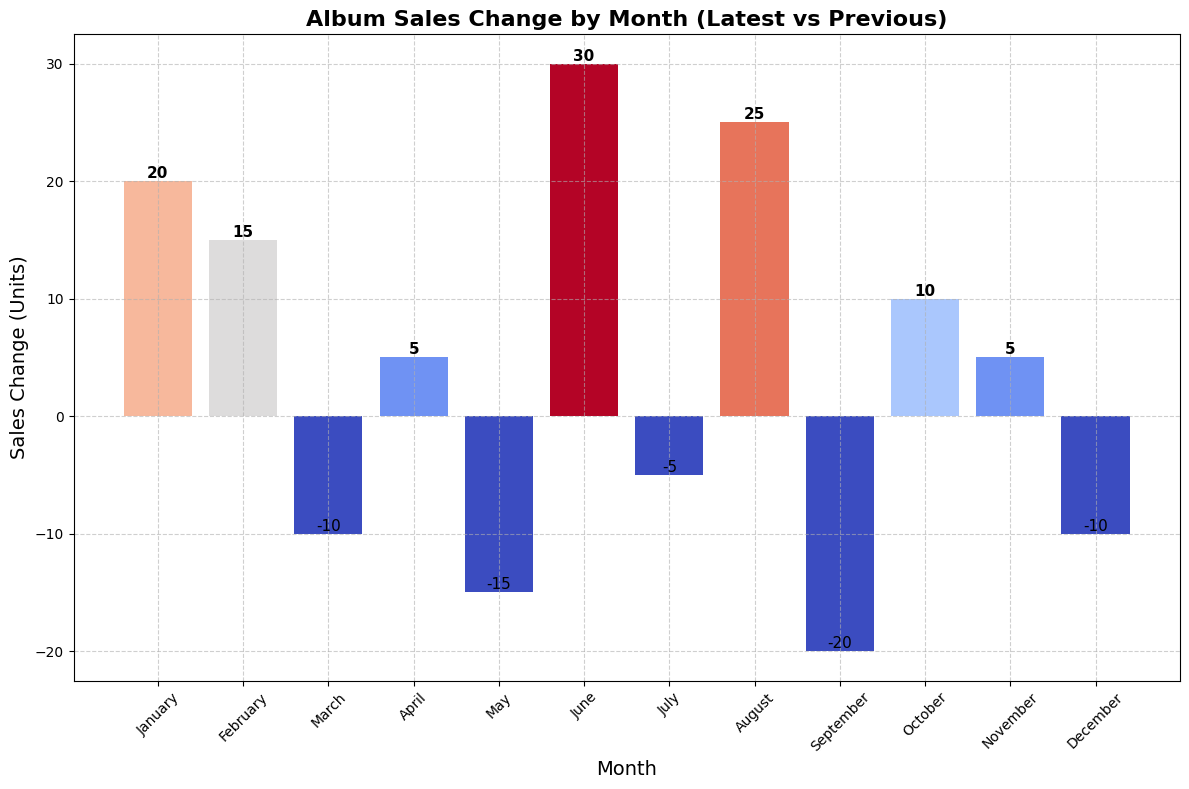what was the total sales change during the positive months? Identify the months with a positive sales change and sum their values. Positive changes occurred in January (+20), February (+15), April (+5), June (+30), August (+25), October (+10), and November (+5). Adding them: 20 + 15 + 5 + 30 + 25 + 10 + 5 = 110.
Answer: 110 What was the median sales change value for the year? Arrange the sales changes in ascending order and find the middle value. Ranked changes: -20, -15, -10, -10, -5, 5, 5, 10, 15, 20, 25, 30. With 12 values, the median is the average of the 6th and 7th values: (5 + 5) / 2 = 5.
Answer: 5 Which month had the highest negative sales change compared to the previous record? Identify the bar with the greatest height below zero. The most negative value is for September at -20.
Answer: September How many months experienced a sales decrease compared to the previous record? Count the number of bars below the zero line. The months with a decrease are March, May, July, September, and December, totaling 5 months.
Answer: 5 In which months was the sales change at least 20 units? Identify months where the bar height is 20 units or more. The months are January (20), June (30), and August (25).
Answer: January, June, August Compare the sales change between February and July. Which was higher? Look at the heights of the bars for February and July. February has a positive change of 15, and July has a negative change of -5. February is higher.
Answer: February Which month had no change or exactly zero sales change compared to the previous record? Identify any bar positioned exactly on the zero line. There is no month with a zero sales change as all values are either positive or negative.
Answer: None What was the average sales change for the months of April, May, and June? Calculate the average of sales changes in these months: April (+5), May (-15), June (+30). Sum them up: 5 + (-15) + 30 = 20, and then divide by 3: 20 / 3 ≈ 6.67.
Answer: 6.67 